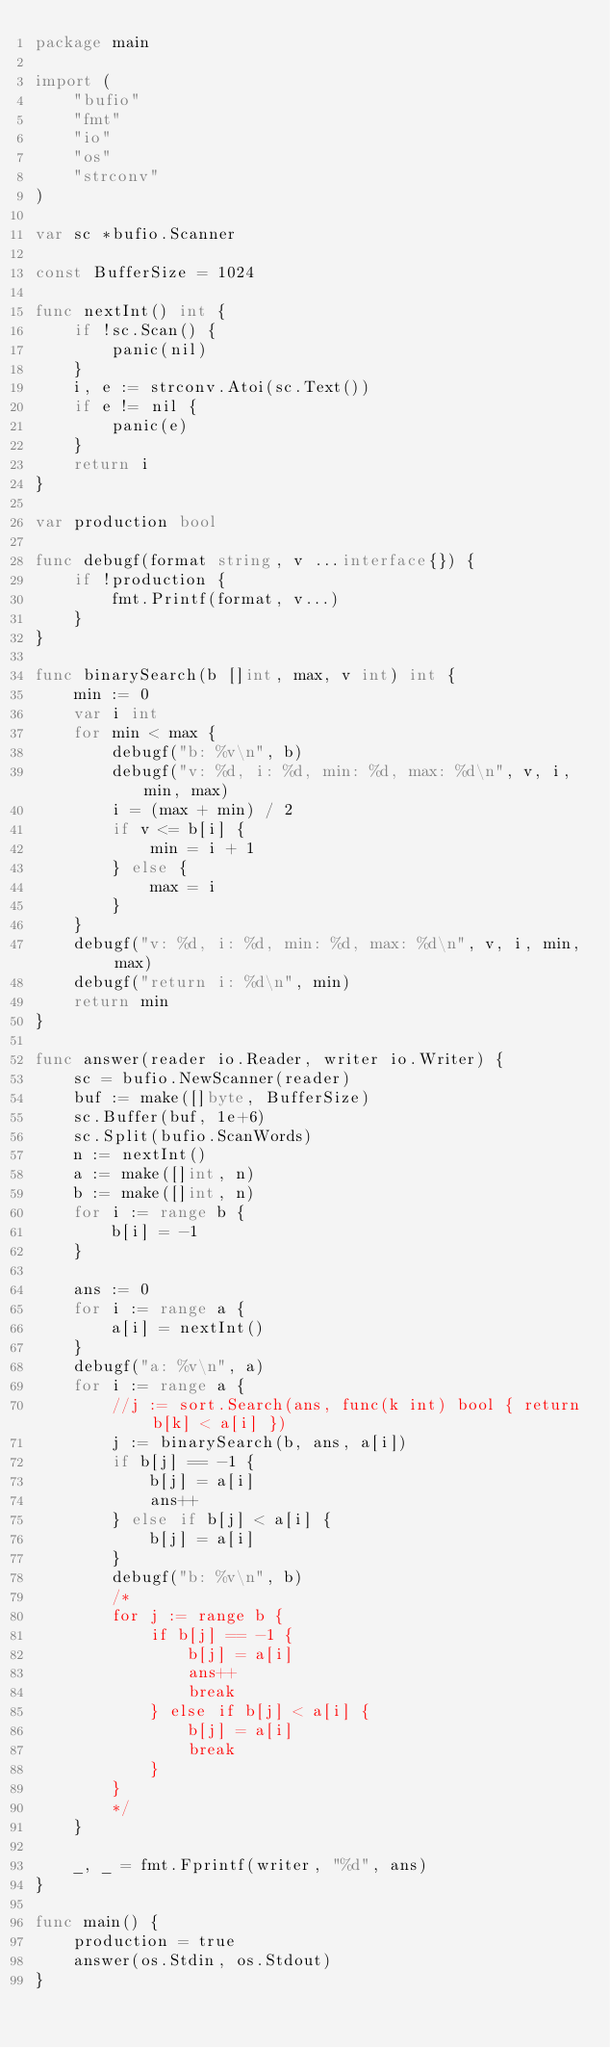Convert code to text. <code><loc_0><loc_0><loc_500><loc_500><_Go_>package main

import (
	"bufio"
	"fmt"
	"io"
	"os"
	"strconv"
)

var sc *bufio.Scanner

const BufferSize = 1024

func nextInt() int {
	if !sc.Scan() {
		panic(nil)
	}
	i, e := strconv.Atoi(sc.Text())
	if e != nil {
		panic(e)
	}
	return i
}

var production bool

func debugf(format string, v ...interface{}) {
	if !production {
		fmt.Printf(format, v...)
	}
}

func binarySearch(b []int, max, v int) int {
	min := 0
	var i int
	for min < max {
		debugf("b: %v\n", b)
		debugf("v: %d, i: %d, min: %d, max: %d\n", v, i, min, max)
		i = (max + min) / 2
		if v <= b[i] {
			min = i + 1
		} else {
			max = i
		}
	}
	debugf("v: %d, i: %d, min: %d, max: %d\n", v, i, min, max)
	debugf("return i: %d\n", min)
	return min
}

func answer(reader io.Reader, writer io.Writer) {
	sc = bufio.NewScanner(reader)
	buf := make([]byte, BufferSize)
	sc.Buffer(buf, 1e+6)
	sc.Split(bufio.ScanWords)
	n := nextInt()
	a := make([]int, n)
	b := make([]int, n)
	for i := range b {
		b[i] = -1
	}

	ans := 0
	for i := range a {
		a[i] = nextInt()
	}
	debugf("a: %v\n", a)
	for i := range a {
		//j := sort.Search(ans, func(k int) bool { return b[k] < a[i] })
		j := binarySearch(b, ans, a[i])
		if b[j] == -1 {
			b[j] = a[i]
			ans++
		} else if b[j] < a[i] {
			b[j] = a[i]
		}
		debugf("b: %v\n", b)
		/*
		for j := range b {
			if b[j] == -1 {
				b[j] = a[i]
				ans++
				break
			} else if b[j] < a[i] {
				b[j] = a[i]
				break
			}
		}
		*/
	}

	_, _ = fmt.Fprintf(writer, "%d", ans)
}

func main() {
	production = true
	answer(os.Stdin, os.Stdout)
}
</code> 